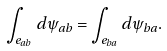Convert formula to latex. <formula><loc_0><loc_0><loc_500><loc_500>\int _ { e _ { a b } } d \psi _ { a b } = \int _ { e _ { b a } } d \psi _ { b a } .</formula> 